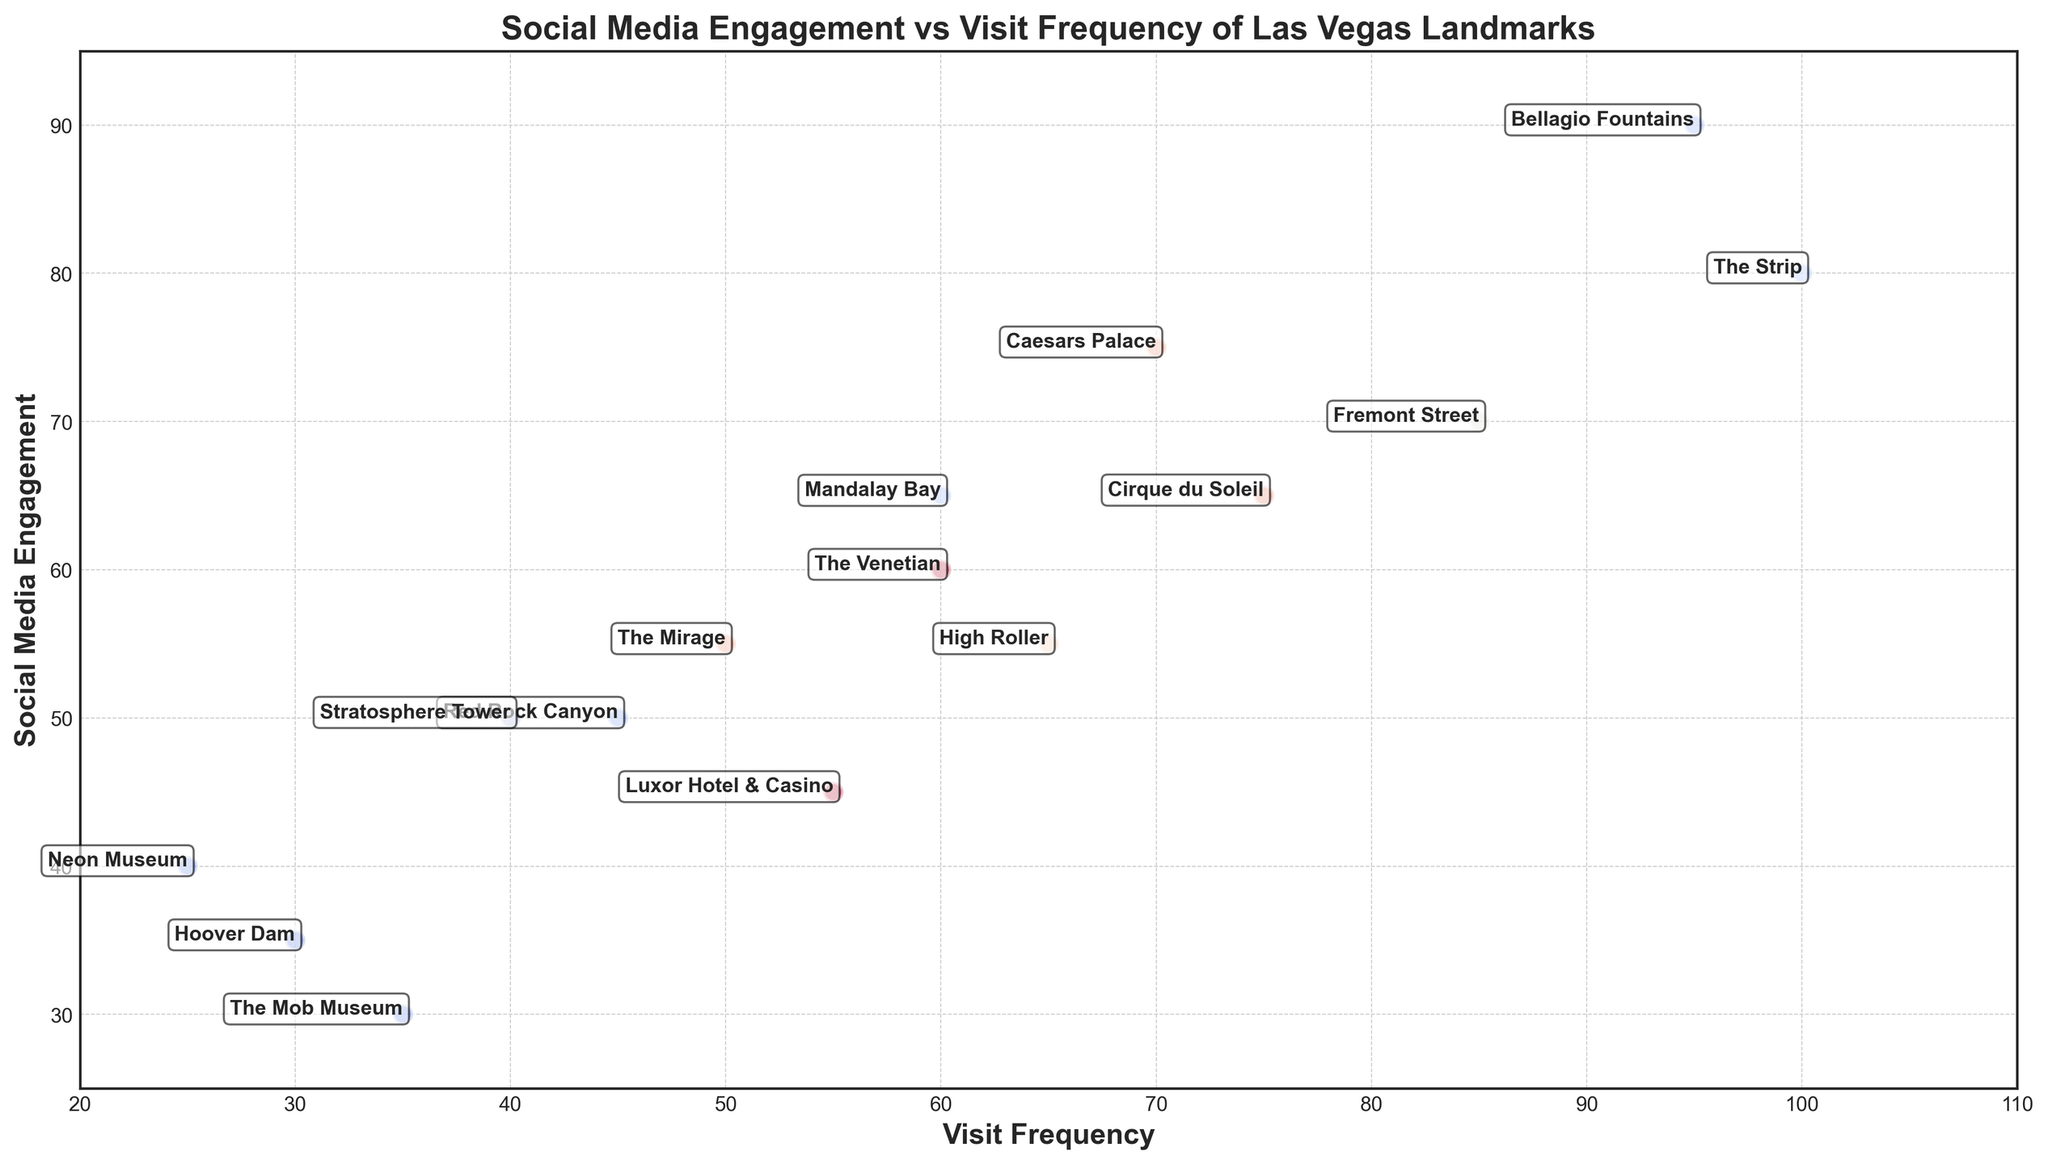What landmark has the highest visit frequency? The data shows that "The Strip" has the highest visit frequency value which is 100.
Answer: The Strip Which landmark has the lowest social media engagement? The data indicates that "The Mob Museum" has the lowest social media engagement value which is 30.
Answer: The Mob Museum How many landmarks have a higher visit frequency than "Luxor Hotel & Casino"? "Luxor Hotel & Casino" has a visit frequency of 55. Comparing this with the other landmarks, six landmarks have visit frequencies higher than 55: Bellagio Fountains, The Strip, Fremont Street, Caesars Palace, The Venetian, and Mandalay Bay.
Answer: 6 Which landmarks have both visit frequency and social media engagement above 80? The data shows that only "Bellagio Fountains" has both visit frequency (95) and social media engagement (90) above 80.
Answer: Bellagio Fountains What is the average social media engagement of all landmarks? To calculate the average, sum up all social media engagement values and divide by the number of landmarks. Sum = 90 + 80 + 70 + 75 + 60 + 55 + 50 + 45 + 65 + 50 + 35 + 55 + 65 + 30 + 40 = 865. There are 15 landmarks. So, average engagement = 865 / 15 ≈ 57.67
Answer: 57.67 What is the difference in visit frequency between "The Strip" and "Fremont Street"? "The Strip" has a visit frequency of 100 and "Fremont Street" has 85. The difference is 100 - 85 = 15.
Answer: 15 Which landmark has the largest gap between its visit frequency and social media engagement? Calculating the gaps: Bellagio Fountains = 5, The Strip = 20, Fremont Street = 15, Caesars Palace = -5, The Venetian = 0, The Mirage = -5, Red Rock Canyon = -5, Luxor Hotel & Casino = 10, Mandalay Bay = -5, Stratosphere Tower = -10, Hoover Dam = -5, High Roller = 10, Cirque du Soleil = 10, The Mob Museum = 5, Neon Museum = 15. The largest absolute gap is 20 for "The Strip".
Answer: The Strip Which landmark between "Caesars Palace" and "High Roller" has higher social media engagement? "Caesars Palace" has a social media engagement of 75, while "High Roller" has an engagement of 55. Therefore, "Caesars Palace" has the higher social media engagement.
Answer: Caesars Palace 